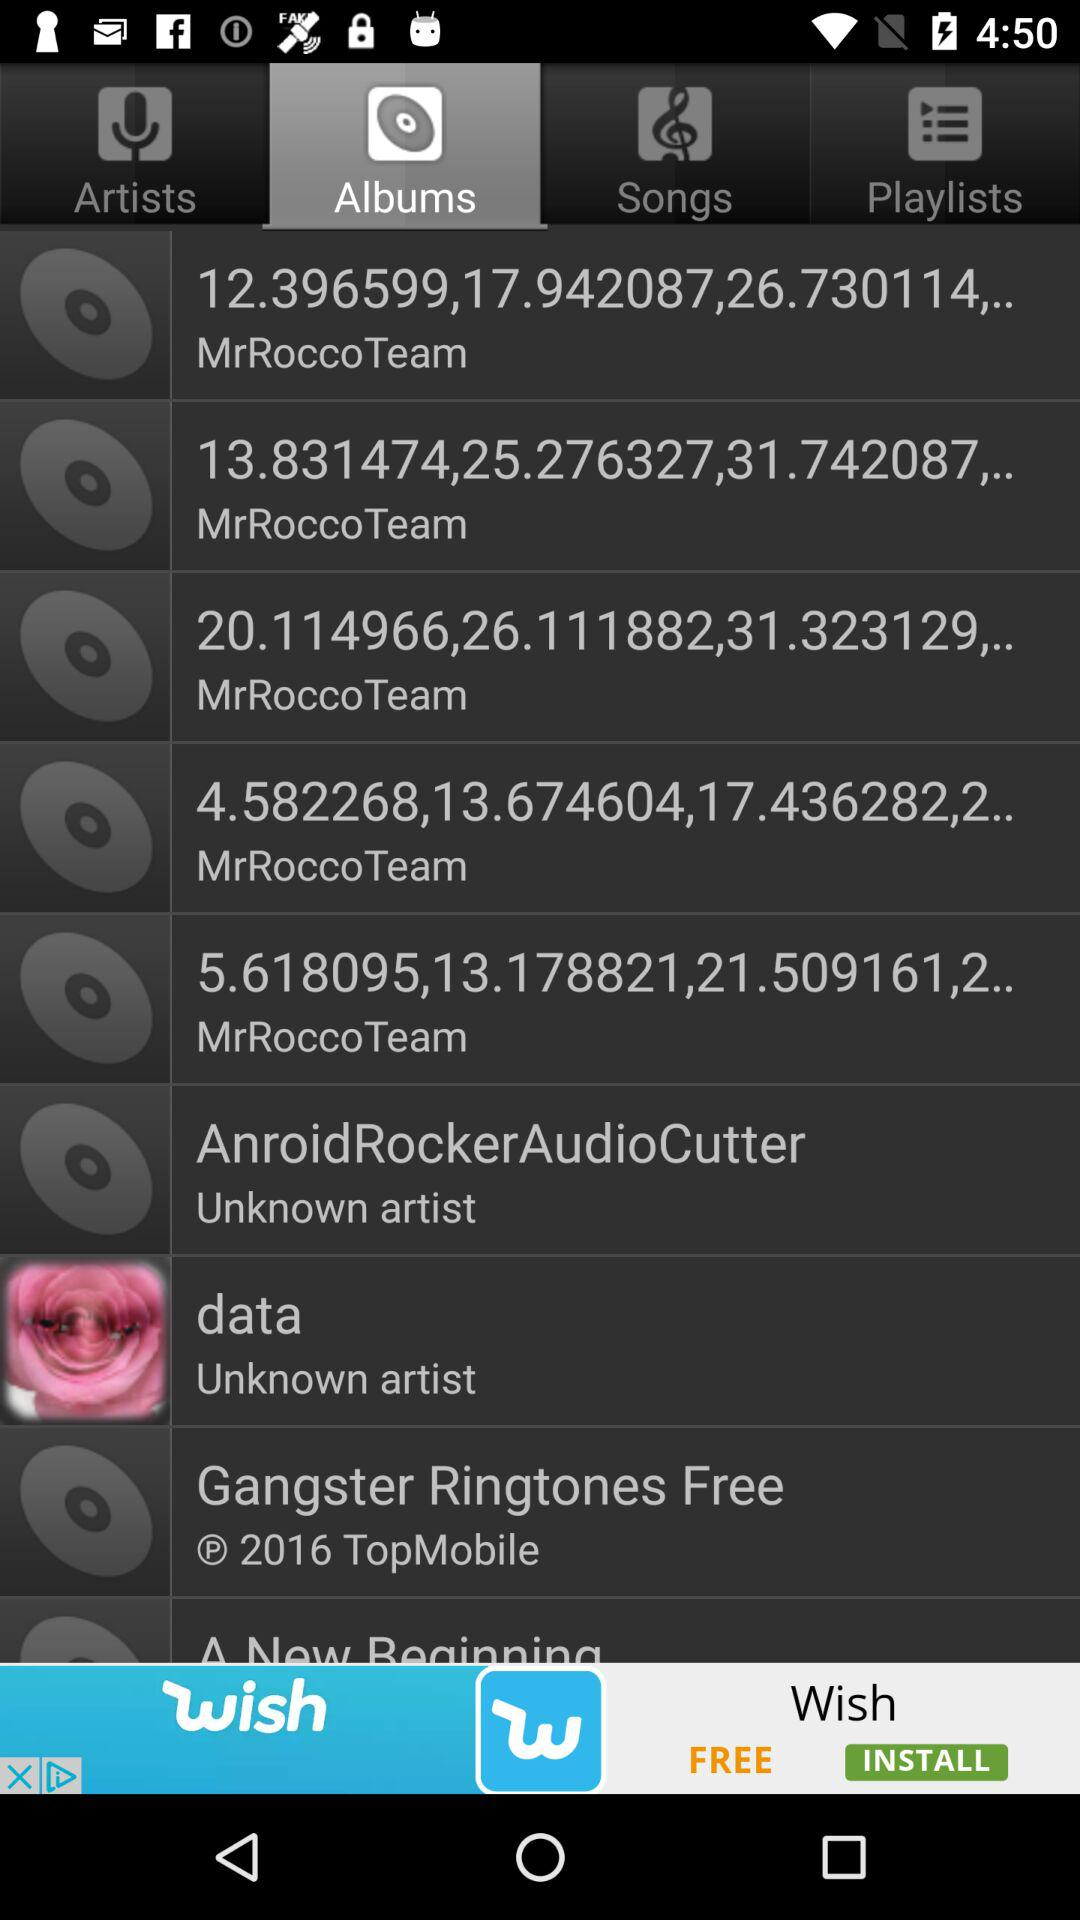What is the selected tab? The selected tab is "Albums". 